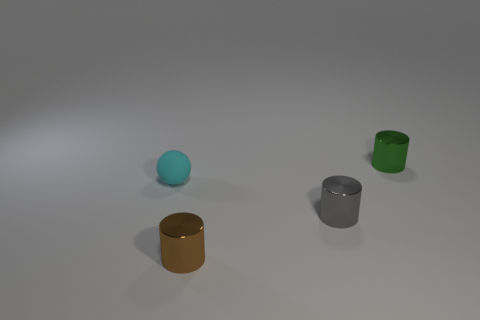Can you describe the lighting of the scene where these objects are placed? The scene is illuminated by a soft, diffused light source that casts gentle shadows beneath the objects, indicating an evenly lit environment that could be indicative of an indoor setting with ambient lighting. 